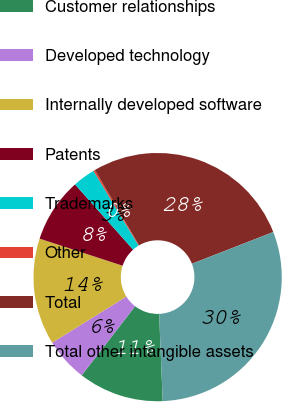Convert chart. <chart><loc_0><loc_0><loc_500><loc_500><pie_chart><fcel>Customer relationships<fcel>Developed technology<fcel>Internally developed software<fcel>Patents<fcel>Trademarks<fcel>Other<fcel>Total<fcel>Total other intangible assets<nl><fcel>11.13%<fcel>5.67%<fcel>13.87%<fcel>8.4%<fcel>2.94%<fcel>0.21%<fcel>27.52%<fcel>30.26%<nl></chart> 